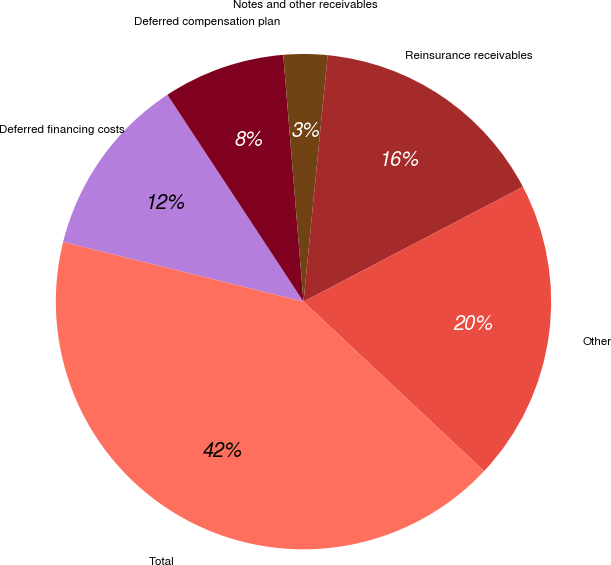<chart> <loc_0><loc_0><loc_500><loc_500><pie_chart><fcel>Deferred financing costs<fcel>Deferred compensation plan<fcel>Notes and other receivables<fcel>Reinsurance receivables<fcel>Other<fcel>Total<nl><fcel>11.87%<fcel>7.96%<fcel>2.86%<fcel>15.77%<fcel>19.67%<fcel>41.88%<nl></chart> 